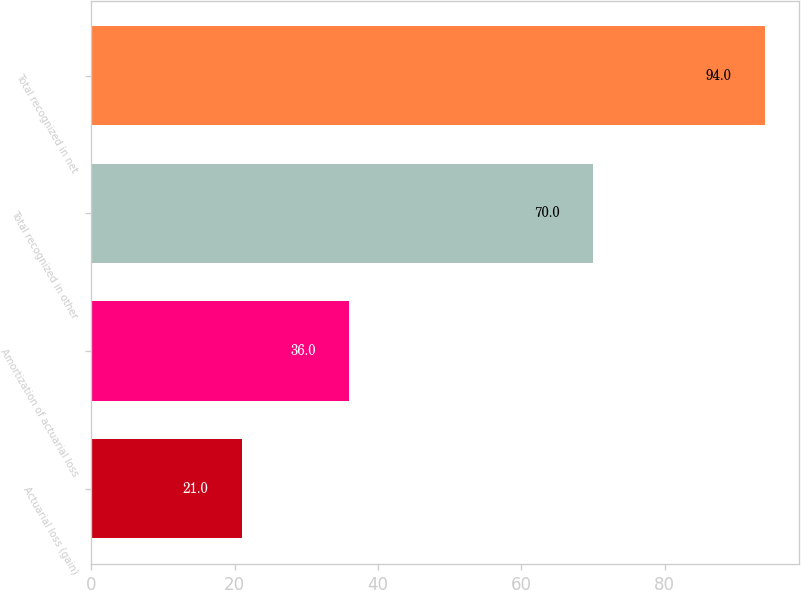<chart> <loc_0><loc_0><loc_500><loc_500><bar_chart><fcel>Actuarial loss (gain)<fcel>Amortization of actuarial loss<fcel>Total recognized in other<fcel>Total recognized in net<nl><fcel>21<fcel>36<fcel>70<fcel>94<nl></chart> 